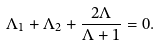Convert formula to latex. <formula><loc_0><loc_0><loc_500><loc_500>\Lambda _ { 1 } + \Lambda _ { 2 } + \frac { 2 \Lambda } { \Lambda + 1 } = 0 .</formula> 